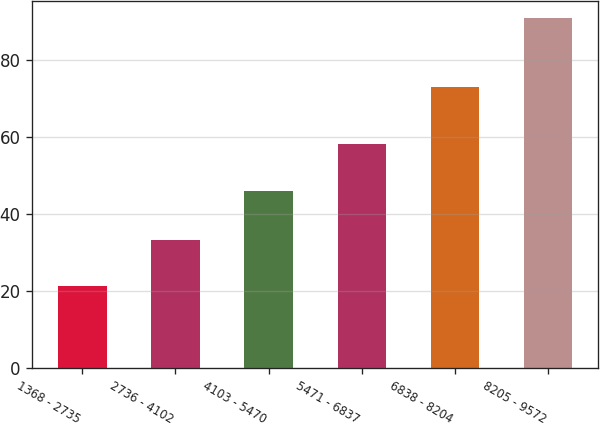Convert chart. <chart><loc_0><loc_0><loc_500><loc_500><bar_chart><fcel>1368 - 2735<fcel>2736 - 4102<fcel>4103 - 5470<fcel>5471 - 6837<fcel>6838 - 8204<fcel>8205 - 9572<nl><fcel>21.35<fcel>33.16<fcel>45.94<fcel>58.15<fcel>72.89<fcel>90.74<nl></chart> 